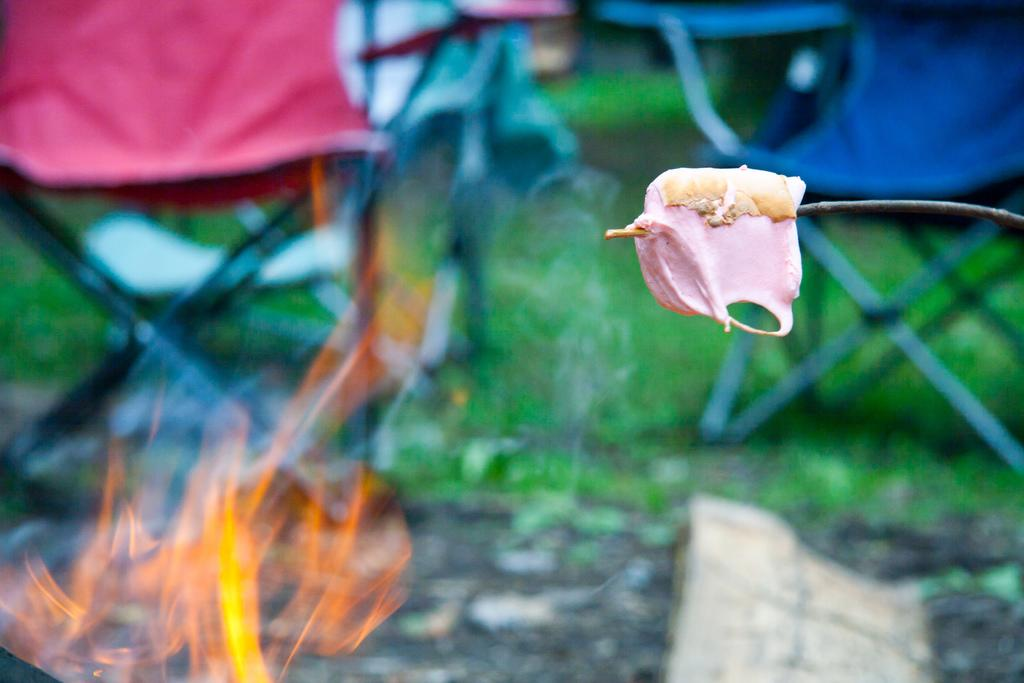What type of food object can be seen in the foreground of the image? There is a food object on a stem in the foreground of the image. What can be seen in the background of the image? There is fire and grassy land visible in the background of the image. Are there any objects for sitting in the background of the image? Yes, there are chairs in the background of the image. What type of curtain can be seen hanging from the food object in the image? There is no curtain present in the image; it features a food object on a stem in the foreground and fire, grassy land, and chairs in the background. 